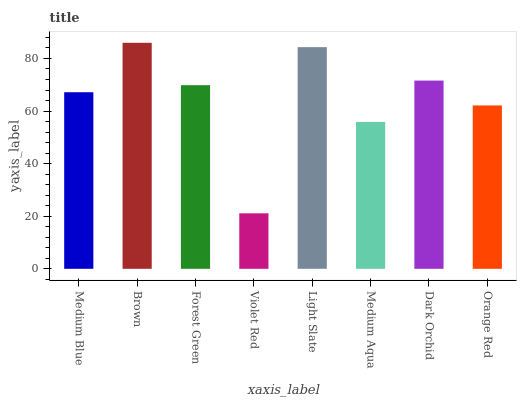Is Violet Red the minimum?
Answer yes or no. Yes. Is Brown the maximum?
Answer yes or no. Yes. Is Forest Green the minimum?
Answer yes or no. No. Is Forest Green the maximum?
Answer yes or no. No. Is Brown greater than Forest Green?
Answer yes or no. Yes. Is Forest Green less than Brown?
Answer yes or no. Yes. Is Forest Green greater than Brown?
Answer yes or no. No. Is Brown less than Forest Green?
Answer yes or no. No. Is Forest Green the high median?
Answer yes or no. Yes. Is Medium Blue the low median?
Answer yes or no. Yes. Is Medium Blue the high median?
Answer yes or no. No. Is Dark Orchid the low median?
Answer yes or no. No. 